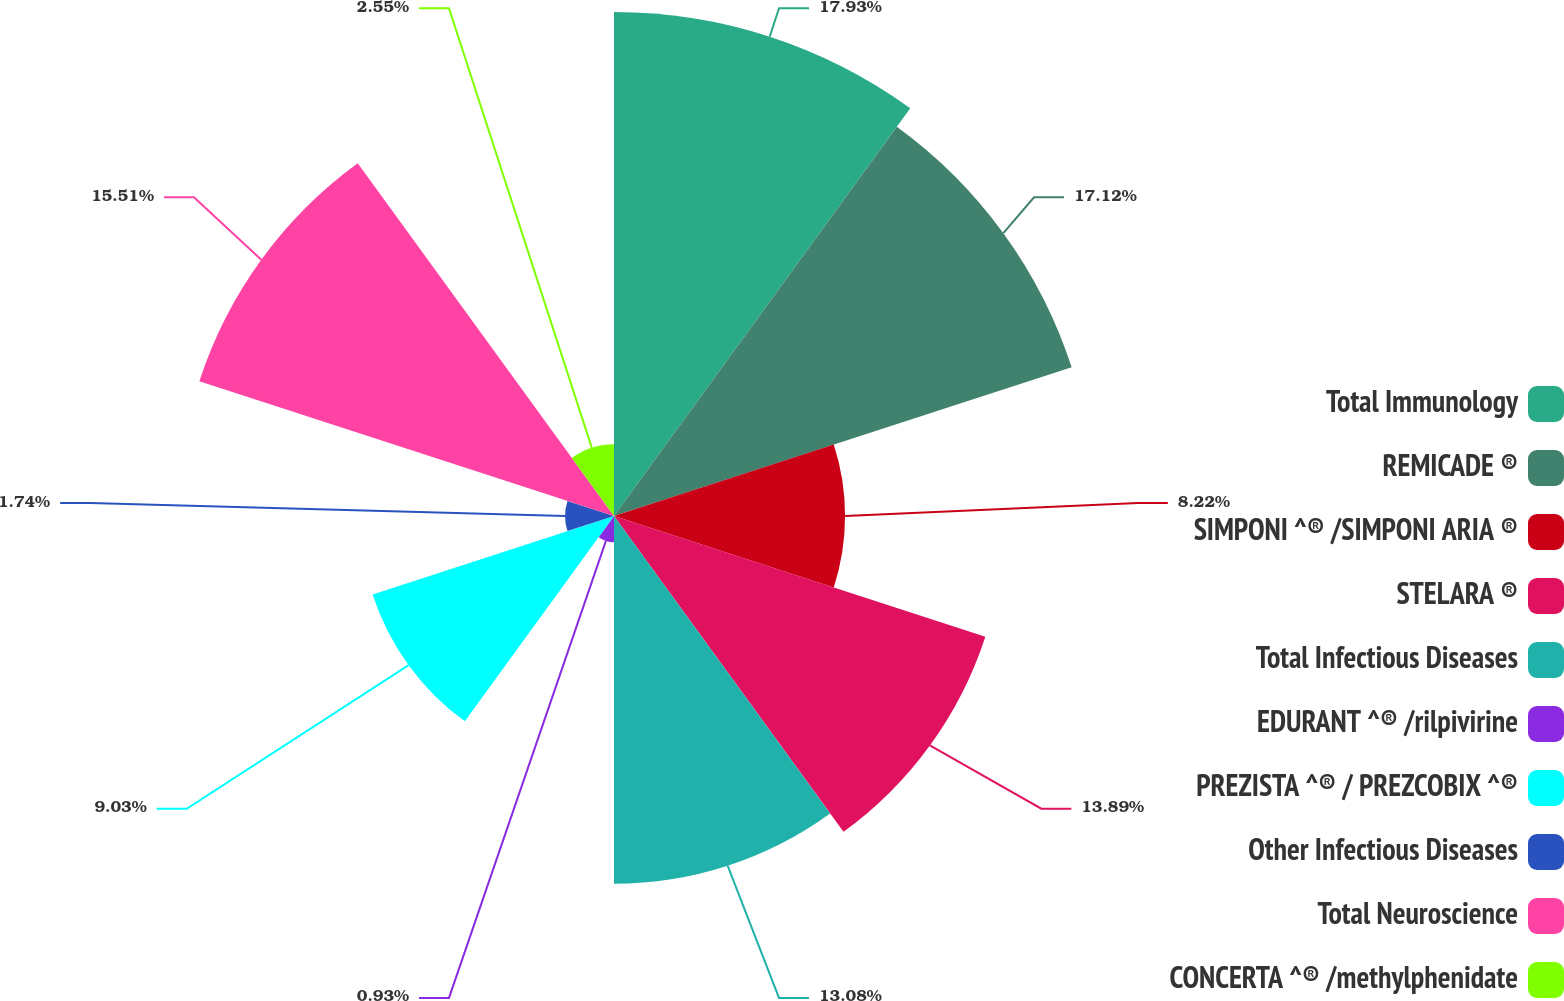<chart> <loc_0><loc_0><loc_500><loc_500><pie_chart><fcel>Total Immunology<fcel>REMICADE ®<fcel>SIMPONI ^® /SIMPONI ARIA ®<fcel>STELARA ®<fcel>Total Infectious Diseases<fcel>EDURANT ^® /rilpivirine<fcel>PREZISTA ^® / PREZCOBIX ^®<fcel>Other Infectious Diseases<fcel>Total Neuroscience<fcel>CONCERTA ^® /methylphenidate<nl><fcel>17.93%<fcel>17.12%<fcel>8.22%<fcel>13.89%<fcel>13.08%<fcel>0.93%<fcel>9.03%<fcel>1.74%<fcel>15.51%<fcel>2.55%<nl></chart> 